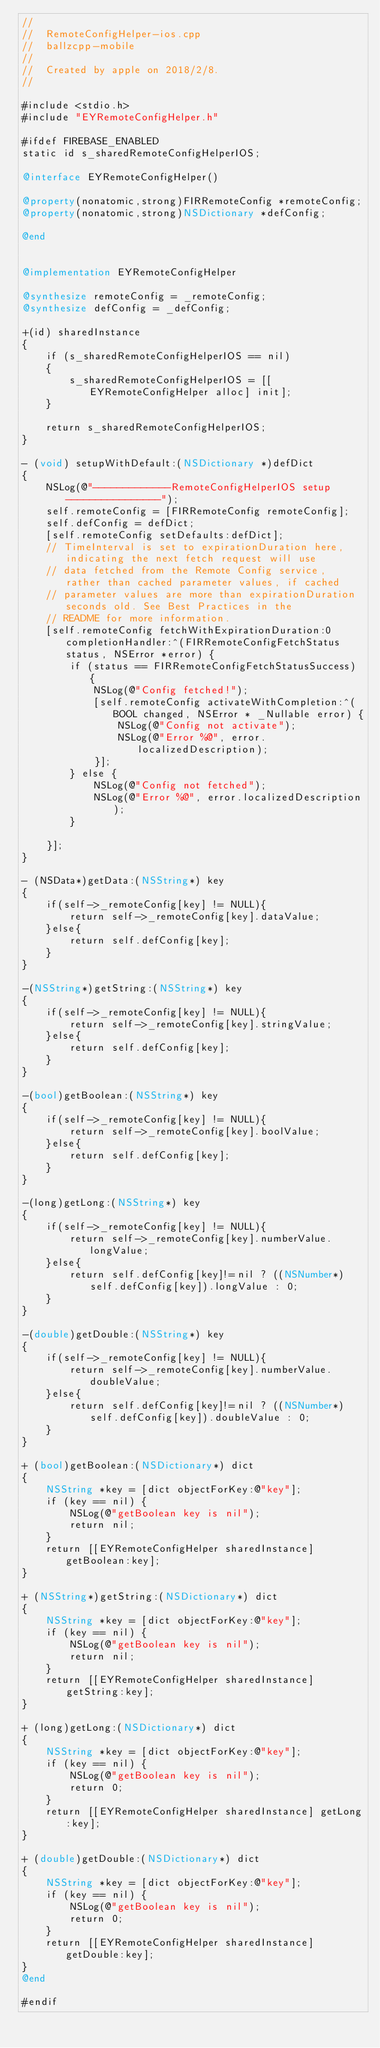Convert code to text. <code><loc_0><loc_0><loc_500><loc_500><_ObjectiveC_>//
//  RemoteConfigHelper-ios.cpp
//  ballzcpp-mobile
//
//  Created by apple on 2018/2/8.
//

#include <stdio.h>
#include "EYRemoteConfigHelper.h"

#ifdef FIREBASE_ENABLED
static id s_sharedRemoteConfigHelperIOS;

@interface EYRemoteConfigHelper()

@property(nonatomic,strong)FIRRemoteConfig *remoteConfig;
@property(nonatomic,strong)NSDictionary *defConfig;

@end


@implementation EYRemoteConfigHelper

@synthesize remoteConfig = _remoteConfig;
@synthesize defConfig = _defConfig;

+(id) sharedInstance
{
    if (s_sharedRemoteConfigHelperIOS == nil)
    {
        s_sharedRemoteConfigHelperIOS = [[EYRemoteConfigHelper alloc] init];
    }
    
    return s_sharedRemoteConfigHelperIOS;
}

- (void) setupWithDefault:(NSDictionary *)defDict
{
    NSLog(@"-------------RemoteConfigHelperIOS setup----------------");
    self.remoteConfig = [FIRRemoteConfig remoteConfig];
    self.defConfig = defDict;
    [self.remoteConfig setDefaults:defDict];
    // TimeInterval is set to expirationDuration here, indicating the next fetch request will use
    // data fetched from the Remote Config service, rather than cached parameter values, if cached
    // parameter values are more than expirationDuration seconds old. See Best Practices in the
    // README for more information.
    [self.remoteConfig fetchWithExpirationDuration:0 completionHandler:^(FIRRemoteConfigFetchStatus status, NSError *error) {
        if (status == FIRRemoteConfigFetchStatusSuccess) {
            NSLog(@"Config fetched!");
            [self.remoteConfig activateWithCompletion:^(BOOL changed, NSError * _Nullable error) {
                NSLog(@"Config not activate");
                NSLog(@"Error %@", error.localizedDescription);
            }];
        } else {
            NSLog(@"Config not fetched");
            NSLog(@"Error %@", error.localizedDescription);
        }

    }];
}

- (NSData*)getData:(NSString*) key
{
    if(self->_remoteConfig[key] != NULL){
        return self->_remoteConfig[key].dataValue;
    }else{
        return self.defConfig[key];
    }
}

-(NSString*)getString:(NSString*) key
{
    if(self->_remoteConfig[key] != NULL){
        return self->_remoteConfig[key].stringValue;
    }else{
        return self.defConfig[key];
    }
}

-(bool)getBoolean:(NSString*) key
{
    if(self->_remoteConfig[key] != NULL){
        return self->_remoteConfig[key].boolValue;
    }else{
        return self.defConfig[key];
    }
}

-(long)getLong:(NSString*) key
{
    if(self->_remoteConfig[key] != NULL){
        return self->_remoteConfig[key].numberValue.longValue;
    }else{
        return self.defConfig[key]!=nil ? ((NSNumber*)self.defConfig[key]).longValue : 0;
    }
}

-(double)getDouble:(NSString*) key
{
    if(self->_remoteConfig[key] != NULL){
        return self->_remoteConfig[key].numberValue.doubleValue;
    }else{
        return self.defConfig[key]!=nil ? ((NSNumber*)self.defConfig[key]).doubleValue : 0;
    }
}

+ (bool)getBoolean:(NSDictionary*) dict
{
    NSString *key = [dict objectForKey:@"key"];
    if (key == nil) {
        NSLog(@"getBoolean key is nil");
        return nil;
    }
    return [[EYRemoteConfigHelper sharedInstance] getBoolean:key];
}

+ (NSString*)getString:(NSDictionary*) dict
{
    NSString *key = [dict objectForKey:@"key"];
    if (key == nil) {
        NSLog(@"getBoolean key is nil");
        return nil;
    }
    return [[EYRemoteConfigHelper sharedInstance] getString:key];
}

+ (long)getLong:(NSDictionary*) dict
{
    NSString *key = [dict objectForKey:@"key"];
    if (key == nil) {
        NSLog(@"getBoolean key is nil");
        return 0;
    }
    return [[EYRemoteConfigHelper sharedInstance] getLong:key];
}

+ (double)getDouble:(NSDictionary*) dict
{
    NSString *key = [dict objectForKey:@"key"];
    if (key == nil) {
        NSLog(@"getBoolean key is nil");
        return 0;
    }
    return [[EYRemoteConfigHelper sharedInstance] getDouble:key];
}
@end

#endif
</code> 